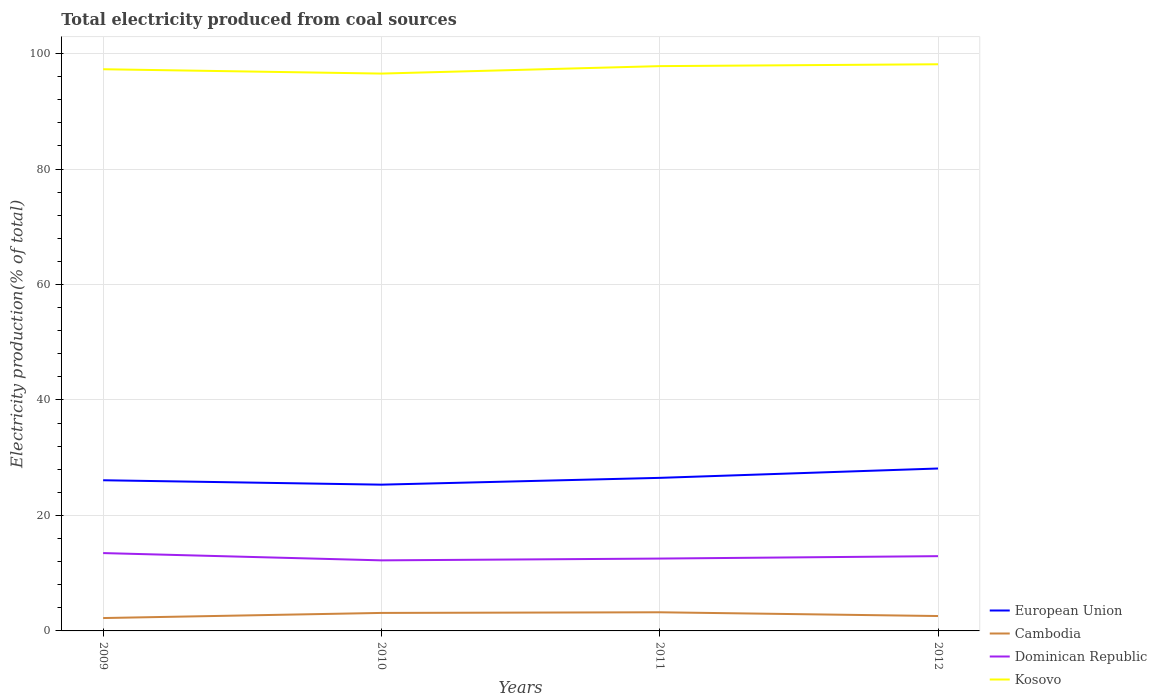How many different coloured lines are there?
Offer a very short reply. 4. Does the line corresponding to Cambodia intersect with the line corresponding to Dominican Republic?
Keep it short and to the point. No. Across all years, what is the maximum total electricity produced in Kosovo?
Provide a short and direct response. 96.54. What is the total total electricity produced in Cambodia in the graph?
Keep it short and to the point. -0.11. What is the difference between the highest and the second highest total electricity produced in Kosovo?
Ensure brevity in your answer.  1.61. How many years are there in the graph?
Ensure brevity in your answer.  4. Are the values on the major ticks of Y-axis written in scientific E-notation?
Offer a very short reply. No. Does the graph contain any zero values?
Give a very brief answer. No. Does the graph contain grids?
Make the answer very short. Yes. How many legend labels are there?
Offer a very short reply. 4. How are the legend labels stacked?
Your answer should be very brief. Vertical. What is the title of the graph?
Your answer should be compact. Total electricity produced from coal sources. What is the label or title of the Y-axis?
Offer a terse response. Electricity production(% of total). What is the Electricity production(% of total) in European Union in 2009?
Provide a succinct answer. 26.1. What is the Electricity production(% of total) of Cambodia in 2009?
Provide a short and direct response. 2.23. What is the Electricity production(% of total) in Dominican Republic in 2009?
Your answer should be very brief. 13.48. What is the Electricity production(% of total) in Kosovo in 2009?
Ensure brevity in your answer.  97.29. What is the Electricity production(% of total) in European Union in 2010?
Ensure brevity in your answer.  25.33. What is the Electricity production(% of total) in Cambodia in 2010?
Make the answer very short. 3.12. What is the Electricity production(% of total) of Dominican Republic in 2010?
Offer a very short reply. 12.22. What is the Electricity production(% of total) of Kosovo in 2010?
Offer a very short reply. 96.54. What is the Electricity production(% of total) of European Union in 2011?
Give a very brief answer. 26.51. What is the Electricity production(% of total) of Cambodia in 2011?
Provide a short and direct response. 3.23. What is the Electricity production(% of total) in Dominican Republic in 2011?
Ensure brevity in your answer.  12.53. What is the Electricity production(% of total) of Kosovo in 2011?
Your answer should be very brief. 97.83. What is the Electricity production(% of total) in European Union in 2012?
Your answer should be very brief. 28.13. What is the Electricity production(% of total) in Cambodia in 2012?
Keep it short and to the point. 2.58. What is the Electricity production(% of total) in Dominican Republic in 2012?
Your answer should be compact. 12.95. What is the Electricity production(% of total) of Kosovo in 2012?
Your response must be concise. 98.15. Across all years, what is the maximum Electricity production(% of total) in European Union?
Your answer should be very brief. 28.13. Across all years, what is the maximum Electricity production(% of total) of Cambodia?
Provide a short and direct response. 3.23. Across all years, what is the maximum Electricity production(% of total) in Dominican Republic?
Make the answer very short. 13.48. Across all years, what is the maximum Electricity production(% of total) in Kosovo?
Keep it short and to the point. 98.15. Across all years, what is the minimum Electricity production(% of total) of European Union?
Your answer should be compact. 25.33. Across all years, what is the minimum Electricity production(% of total) in Cambodia?
Provide a short and direct response. 2.23. Across all years, what is the minimum Electricity production(% of total) in Dominican Republic?
Provide a succinct answer. 12.22. Across all years, what is the minimum Electricity production(% of total) of Kosovo?
Provide a short and direct response. 96.54. What is the total Electricity production(% of total) in European Union in the graph?
Your answer should be very brief. 106.08. What is the total Electricity production(% of total) of Cambodia in the graph?
Offer a terse response. 11.16. What is the total Electricity production(% of total) of Dominican Republic in the graph?
Your response must be concise. 51.19. What is the total Electricity production(% of total) in Kosovo in the graph?
Provide a short and direct response. 389.8. What is the difference between the Electricity production(% of total) in European Union in 2009 and that in 2010?
Your response must be concise. 0.76. What is the difference between the Electricity production(% of total) of Cambodia in 2009 and that in 2010?
Keep it short and to the point. -0.89. What is the difference between the Electricity production(% of total) of Dominican Republic in 2009 and that in 2010?
Your response must be concise. 1.26. What is the difference between the Electricity production(% of total) in Kosovo in 2009 and that in 2010?
Your answer should be very brief. 0.75. What is the difference between the Electricity production(% of total) in European Union in 2009 and that in 2011?
Offer a terse response. -0.42. What is the difference between the Electricity production(% of total) in Cambodia in 2009 and that in 2011?
Provide a short and direct response. -1. What is the difference between the Electricity production(% of total) in Kosovo in 2009 and that in 2011?
Provide a short and direct response. -0.54. What is the difference between the Electricity production(% of total) of European Union in 2009 and that in 2012?
Your response must be concise. -2.04. What is the difference between the Electricity production(% of total) in Cambodia in 2009 and that in 2012?
Give a very brief answer. -0.35. What is the difference between the Electricity production(% of total) of Dominican Republic in 2009 and that in 2012?
Keep it short and to the point. 0.53. What is the difference between the Electricity production(% of total) of Kosovo in 2009 and that in 2012?
Provide a succinct answer. -0.86. What is the difference between the Electricity production(% of total) of European Union in 2010 and that in 2011?
Your response must be concise. -1.18. What is the difference between the Electricity production(% of total) in Cambodia in 2010 and that in 2011?
Keep it short and to the point. -0.11. What is the difference between the Electricity production(% of total) in Dominican Republic in 2010 and that in 2011?
Provide a short and direct response. -0.31. What is the difference between the Electricity production(% of total) in Kosovo in 2010 and that in 2011?
Your response must be concise. -1.29. What is the difference between the Electricity production(% of total) of European Union in 2010 and that in 2012?
Your answer should be very brief. -2.8. What is the difference between the Electricity production(% of total) of Cambodia in 2010 and that in 2012?
Provide a succinct answer. 0.54. What is the difference between the Electricity production(% of total) of Dominican Republic in 2010 and that in 2012?
Your response must be concise. -0.73. What is the difference between the Electricity production(% of total) of Kosovo in 2010 and that in 2012?
Provide a succinct answer. -1.61. What is the difference between the Electricity production(% of total) in European Union in 2011 and that in 2012?
Offer a terse response. -1.62. What is the difference between the Electricity production(% of total) in Cambodia in 2011 and that in 2012?
Offer a terse response. 0.65. What is the difference between the Electricity production(% of total) of Dominican Republic in 2011 and that in 2012?
Ensure brevity in your answer.  -0.42. What is the difference between the Electricity production(% of total) in Kosovo in 2011 and that in 2012?
Make the answer very short. -0.32. What is the difference between the Electricity production(% of total) of European Union in 2009 and the Electricity production(% of total) of Cambodia in 2010?
Keep it short and to the point. 22.98. What is the difference between the Electricity production(% of total) in European Union in 2009 and the Electricity production(% of total) in Dominican Republic in 2010?
Your answer should be very brief. 13.87. What is the difference between the Electricity production(% of total) in European Union in 2009 and the Electricity production(% of total) in Kosovo in 2010?
Give a very brief answer. -70.44. What is the difference between the Electricity production(% of total) in Cambodia in 2009 and the Electricity production(% of total) in Dominican Republic in 2010?
Your answer should be compact. -9.99. What is the difference between the Electricity production(% of total) of Cambodia in 2009 and the Electricity production(% of total) of Kosovo in 2010?
Keep it short and to the point. -94.31. What is the difference between the Electricity production(% of total) of Dominican Republic in 2009 and the Electricity production(% of total) of Kosovo in 2010?
Provide a short and direct response. -83.05. What is the difference between the Electricity production(% of total) in European Union in 2009 and the Electricity production(% of total) in Cambodia in 2011?
Provide a short and direct response. 22.87. What is the difference between the Electricity production(% of total) of European Union in 2009 and the Electricity production(% of total) of Dominican Republic in 2011?
Your answer should be compact. 13.56. What is the difference between the Electricity production(% of total) in European Union in 2009 and the Electricity production(% of total) in Kosovo in 2011?
Your response must be concise. -71.73. What is the difference between the Electricity production(% of total) in Cambodia in 2009 and the Electricity production(% of total) in Dominican Republic in 2011?
Give a very brief answer. -10.3. What is the difference between the Electricity production(% of total) of Cambodia in 2009 and the Electricity production(% of total) of Kosovo in 2011?
Make the answer very short. -95.6. What is the difference between the Electricity production(% of total) of Dominican Republic in 2009 and the Electricity production(% of total) of Kosovo in 2011?
Offer a very short reply. -84.34. What is the difference between the Electricity production(% of total) of European Union in 2009 and the Electricity production(% of total) of Cambodia in 2012?
Give a very brief answer. 23.52. What is the difference between the Electricity production(% of total) in European Union in 2009 and the Electricity production(% of total) in Dominican Republic in 2012?
Your answer should be compact. 13.15. What is the difference between the Electricity production(% of total) in European Union in 2009 and the Electricity production(% of total) in Kosovo in 2012?
Give a very brief answer. -72.05. What is the difference between the Electricity production(% of total) in Cambodia in 2009 and the Electricity production(% of total) in Dominican Republic in 2012?
Keep it short and to the point. -10.72. What is the difference between the Electricity production(% of total) of Cambodia in 2009 and the Electricity production(% of total) of Kosovo in 2012?
Give a very brief answer. -95.92. What is the difference between the Electricity production(% of total) of Dominican Republic in 2009 and the Electricity production(% of total) of Kosovo in 2012?
Offer a very short reply. -84.67. What is the difference between the Electricity production(% of total) of European Union in 2010 and the Electricity production(% of total) of Cambodia in 2011?
Provide a succinct answer. 22.11. What is the difference between the Electricity production(% of total) of European Union in 2010 and the Electricity production(% of total) of Dominican Republic in 2011?
Offer a very short reply. 12.8. What is the difference between the Electricity production(% of total) of European Union in 2010 and the Electricity production(% of total) of Kosovo in 2011?
Provide a succinct answer. -72.49. What is the difference between the Electricity production(% of total) of Cambodia in 2010 and the Electricity production(% of total) of Dominican Republic in 2011?
Give a very brief answer. -9.41. What is the difference between the Electricity production(% of total) in Cambodia in 2010 and the Electricity production(% of total) in Kosovo in 2011?
Provide a short and direct response. -94.71. What is the difference between the Electricity production(% of total) of Dominican Republic in 2010 and the Electricity production(% of total) of Kosovo in 2011?
Offer a very short reply. -85.61. What is the difference between the Electricity production(% of total) of European Union in 2010 and the Electricity production(% of total) of Cambodia in 2012?
Offer a terse response. 22.75. What is the difference between the Electricity production(% of total) of European Union in 2010 and the Electricity production(% of total) of Dominican Republic in 2012?
Your answer should be very brief. 12.38. What is the difference between the Electricity production(% of total) in European Union in 2010 and the Electricity production(% of total) in Kosovo in 2012?
Offer a very short reply. -72.81. What is the difference between the Electricity production(% of total) in Cambodia in 2010 and the Electricity production(% of total) in Dominican Republic in 2012?
Your answer should be very brief. -9.83. What is the difference between the Electricity production(% of total) of Cambodia in 2010 and the Electricity production(% of total) of Kosovo in 2012?
Provide a succinct answer. -95.03. What is the difference between the Electricity production(% of total) in Dominican Republic in 2010 and the Electricity production(% of total) in Kosovo in 2012?
Keep it short and to the point. -85.93. What is the difference between the Electricity production(% of total) of European Union in 2011 and the Electricity production(% of total) of Cambodia in 2012?
Provide a succinct answer. 23.93. What is the difference between the Electricity production(% of total) in European Union in 2011 and the Electricity production(% of total) in Dominican Republic in 2012?
Your response must be concise. 13.56. What is the difference between the Electricity production(% of total) in European Union in 2011 and the Electricity production(% of total) in Kosovo in 2012?
Your answer should be very brief. -71.64. What is the difference between the Electricity production(% of total) in Cambodia in 2011 and the Electricity production(% of total) in Dominican Republic in 2012?
Keep it short and to the point. -9.72. What is the difference between the Electricity production(% of total) in Cambodia in 2011 and the Electricity production(% of total) in Kosovo in 2012?
Offer a terse response. -94.92. What is the difference between the Electricity production(% of total) of Dominican Republic in 2011 and the Electricity production(% of total) of Kosovo in 2012?
Your response must be concise. -85.62. What is the average Electricity production(% of total) of European Union per year?
Your answer should be compact. 26.52. What is the average Electricity production(% of total) of Cambodia per year?
Make the answer very short. 2.79. What is the average Electricity production(% of total) of Dominican Republic per year?
Offer a terse response. 12.8. What is the average Electricity production(% of total) of Kosovo per year?
Your answer should be very brief. 97.45. In the year 2009, what is the difference between the Electricity production(% of total) of European Union and Electricity production(% of total) of Cambodia?
Keep it short and to the point. 23.87. In the year 2009, what is the difference between the Electricity production(% of total) of European Union and Electricity production(% of total) of Dominican Republic?
Offer a terse response. 12.61. In the year 2009, what is the difference between the Electricity production(% of total) in European Union and Electricity production(% of total) in Kosovo?
Give a very brief answer. -71.19. In the year 2009, what is the difference between the Electricity production(% of total) of Cambodia and Electricity production(% of total) of Dominican Republic?
Offer a very short reply. -11.25. In the year 2009, what is the difference between the Electricity production(% of total) in Cambodia and Electricity production(% of total) in Kosovo?
Provide a succinct answer. -95.06. In the year 2009, what is the difference between the Electricity production(% of total) in Dominican Republic and Electricity production(% of total) in Kosovo?
Offer a very short reply. -83.8. In the year 2010, what is the difference between the Electricity production(% of total) of European Union and Electricity production(% of total) of Cambodia?
Offer a terse response. 22.22. In the year 2010, what is the difference between the Electricity production(% of total) of European Union and Electricity production(% of total) of Dominican Republic?
Keep it short and to the point. 13.11. In the year 2010, what is the difference between the Electricity production(% of total) in European Union and Electricity production(% of total) in Kosovo?
Provide a succinct answer. -71.2. In the year 2010, what is the difference between the Electricity production(% of total) of Cambodia and Electricity production(% of total) of Dominican Republic?
Make the answer very short. -9.1. In the year 2010, what is the difference between the Electricity production(% of total) of Cambodia and Electricity production(% of total) of Kosovo?
Offer a very short reply. -93.42. In the year 2010, what is the difference between the Electricity production(% of total) of Dominican Republic and Electricity production(% of total) of Kosovo?
Keep it short and to the point. -84.31. In the year 2011, what is the difference between the Electricity production(% of total) in European Union and Electricity production(% of total) in Cambodia?
Your answer should be very brief. 23.28. In the year 2011, what is the difference between the Electricity production(% of total) in European Union and Electricity production(% of total) in Dominican Republic?
Your response must be concise. 13.98. In the year 2011, what is the difference between the Electricity production(% of total) in European Union and Electricity production(% of total) in Kosovo?
Make the answer very short. -71.32. In the year 2011, what is the difference between the Electricity production(% of total) of Cambodia and Electricity production(% of total) of Dominican Republic?
Your response must be concise. -9.3. In the year 2011, what is the difference between the Electricity production(% of total) in Cambodia and Electricity production(% of total) in Kosovo?
Provide a short and direct response. -94.6. In the year 2011, what is the difference between the Electricity production(% of total) of Dominican Republic and Electricity production(% of total) of Kosovo?
Your response must be concise. -85.29. In the year 2012, what is the difference between the Electricity production(% of total) of European Union and Electricity production(% of total) of Cambodia?
Provide a succinct answer. 25.55. In the year 2012, what is the difference between the Electricity production(% of total) in European Union and Electricity production(% of total) in Dominican Republic?
Provide a succinct answer. 15.18. In the year 2012, what is the difference between the Electricity production(% of total) of European Union and Electricity production(% of total) of Kosovo?
Ensure brevity in your answer.  -70.02. In the year 2012, what is the difference between the Electricity production(% of total) of Cambodia and Electricity production(% of total) of Dominican Republic?
Give a very brief answer. -10.37. In the year 2012, what is the difference between the Electricity production(% of total) in Cambodia and Electricity production(% of total) in Kosovo?
Offer a very short reply. -95.57. In the year 2012, what is the difference between the Electricity production(% of total) in Dominican Republic and Electricity production(% of total) in Kosovo?
Ensure brevity in your answer.  -85.2. What is the ratio of the Electricity production(% of total) in European Union in 2009 to that in 2010?
Your answer should be very brief. 1.03. What is the ratio of the Electricity production(% of total) in Cambodia in 2009 to that in 2010?
Your answer should be very brief. 0.71. What is the ratio of the Electricity production(% of total) in Dominican Republic in 2009 to that in 2010?
Make the answer very short. 1.1. What is the ratio of the Electricity production(% of total) in European Union in 2009 to that in 2011?
Offer a terse response. 0.98. What is the ratio of the Electricity production(% of total) in Cambodia in 2009 to that in 2011?
Your answer should be compact. 0.69. What is the ratio of the Electricity production(% of total) in Dominican Republic in 2009 to that in 2011?
Offer a very short reply. 1.08. What is the ratio of the Electricity production(% of total) of Kosovo in 2009 to that in 2011?
Ensure brevity in your answer.  0.99. What is the ratio of the Electricity production(% of total) of European Union in 2009 to that in 2012?
Offer a terse response. 0.93. What is the ratio of the Electricity production(% of total) of Cambodia in 2009 to that in 2012?
Your response must be concise. 0.86. What is the ratio of the Electricity production(% of total) in Dominican Republic in 2009 to that in 2012?
Give a very brief answer. 1.04. What is the ratio of the Electricity production(% of total) of European Union in 2010 to that in 2011?
Your response must be concise. 0.96. What is the ratio of the Electricity production(% of total) in Cambodia in 2010 to that in 2011?
Give a very brief answer. 0.97. What is the ratio of the Electricity production(% of total) in Dominican Republic in 2010 to that in 2011?
Ensure brevity in your answer.  0.98. What is the ratio of the Electricity production(% of total) of European Union in 2010 to that in 2012?
Make the answer very short. 0.9. What is the ratio of the Electricity production(% of total) in Cambodia in 2010 to that in 2012?
Offer a terse response. 1.21. What is the ratio of the Electricity production(% of total) in Dominican Republic in 2010 to that in 2012?
Offer a terse response. 0.94. What is the ratio of the Electricity production(% of total) of Kosovo in 2010 to that in 2012?
Your response must be concise. 0.98. What is the ratio of the Electricity production(% of total) in European Union in 2011 to that in 2012?
Your answer should be compact. 0.94. What is the ratio of the Electricity production(% of total) in Cambodia in 2011 to that in 2012?
Give a very brief answer. 1.25. What is the ratio of the Electricity production(% of total) of Dominican Republic in 2011 to that in 2012?
Give a very brief answer. 0.97. What is the ratio of the Electricity production(% of total) in Kosovo in 2011 to that in 2012?
Provide a short and direct response. 1. What is the difference between the highest and the second highest Electricity production(% of total) of European Union?
Your answer should be compact. 1.62. What is the difference between the highest and the second highest Electricity production(% of total) of Cambodia?
Give a very brief answer. 0.11. What is the difference between the highest and the second highest Electricity production(% of total) in Dominican Republic?
Make the answer very short. 0.53. What is the difference between the highest and the second highest Electricity production(% of total) in Kosovo?
Offer a very short reply. 0.32. What is the difference between the highest and the lowest Electricity production(% of total) of European Union?
Ensure brevity in your answer.  2.8. What is the difference between the highest and the lowest Electricity production(% of total) of Cambodia?
Make the answer very short. 1. What is the difference between the highest and the lowest Electricity production(% of total) of Dominican Republic?
Keep it short and to the point. 1.26. What is the difference between the highest and the lowest Electricity production(% of total) in Kosovo?
Keep it short and to the point. 1.61. 